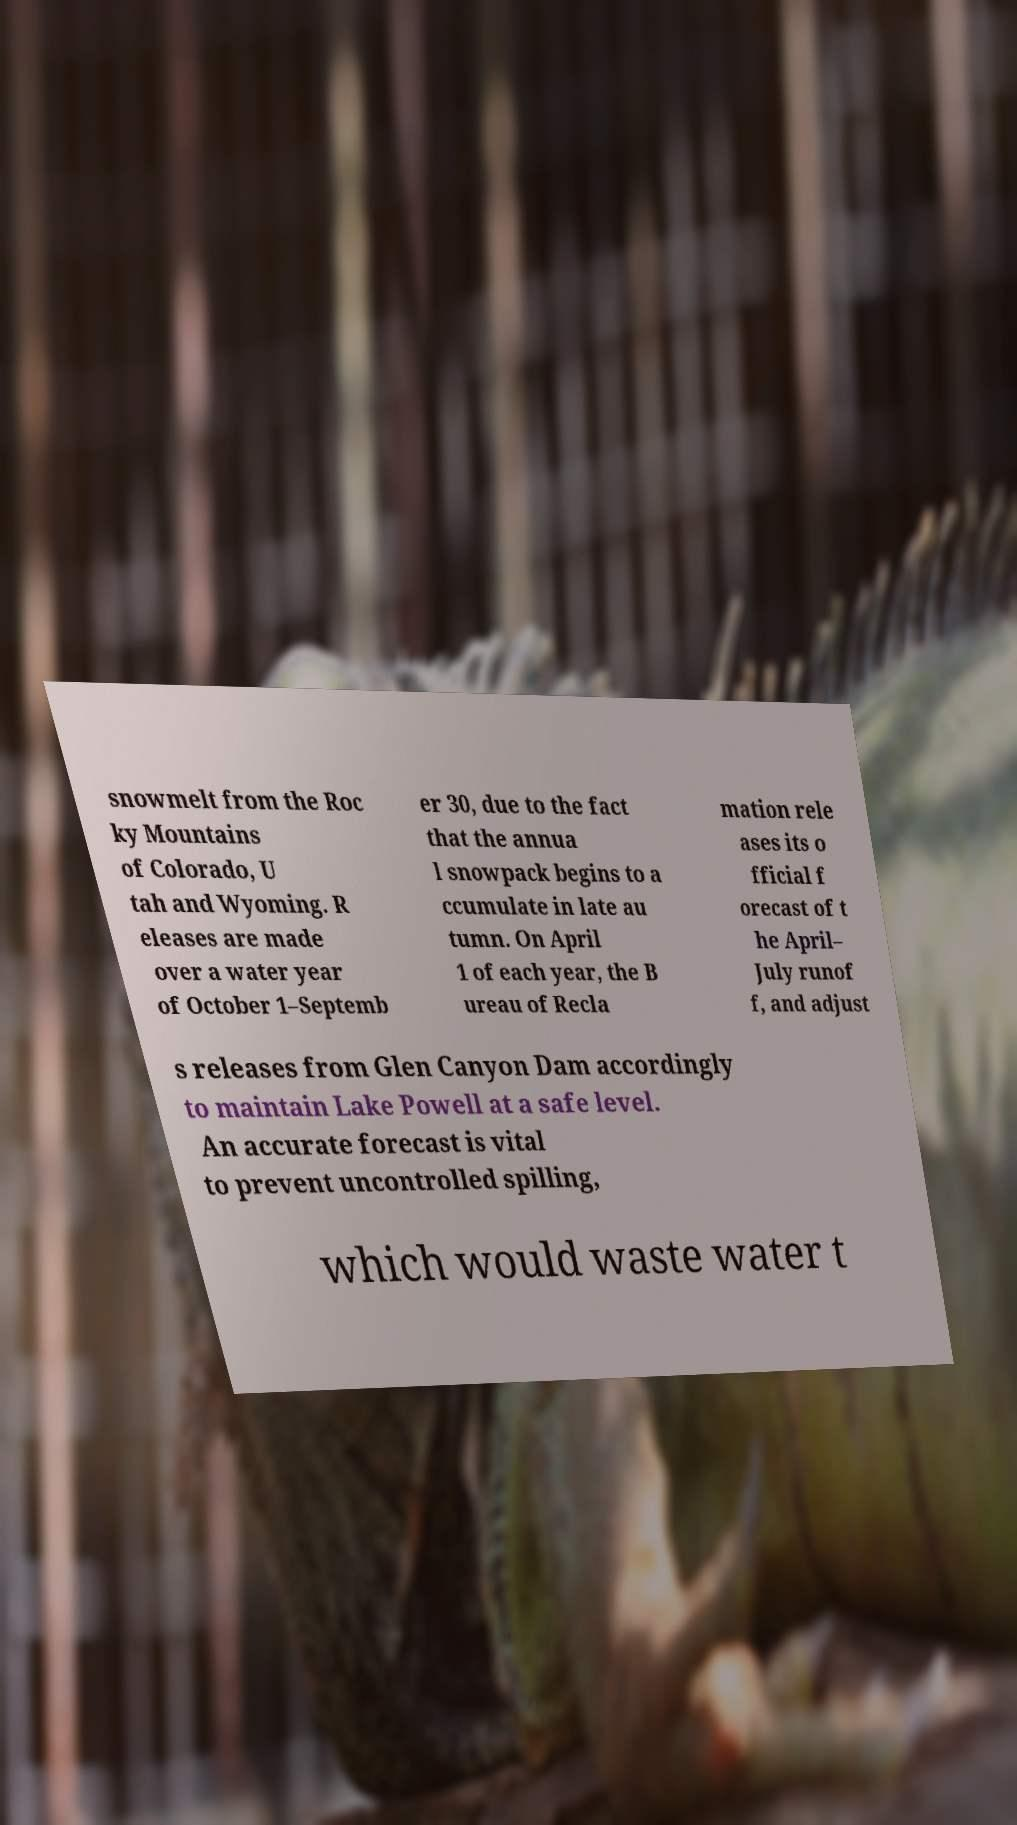I need the written content from this picture converted into text. Can you do that? snowmelt from the Roc ky Mountains of Colorado, U tah and Wyoming. R eleases are made over a water year of October 1–Septemb er 30, due to the fact that the annua l snowpack begins to a ccumulate in late au tumn. On April 1 of each year, the B ureau of Recla mation rele ases its o fficial f orecast of t he April– July runof f, and adjust s releases from Glen Canyon Dam accordingly to maintain Lake Powell at a safe level. An accurate forecast is vital to prevent uncontrolled spilling, which would waste water t 